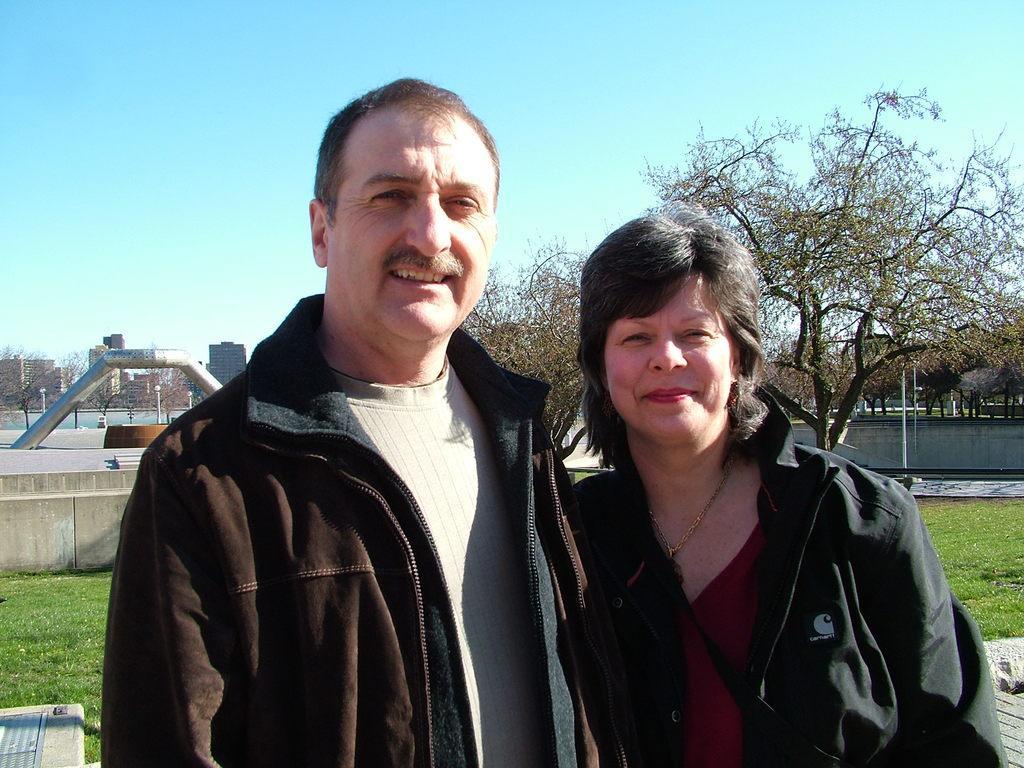Please provide a concise description of this image. In this image there is a man and a woman standing. They are smiling. Behind them there's grass on the ground. In the background there are buildings, trees and poles in the image. At the top there is the sky. 